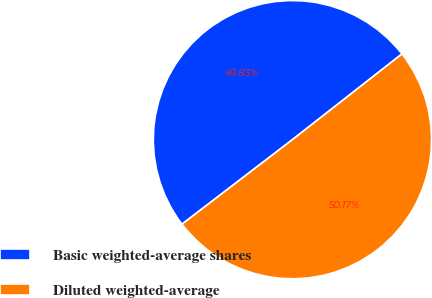Convert chart to OTSL. <chart><loc_0><loc_0><loc_500><loc_500><pie_chart><fcel>Basic weighted-average shares<fcel>Diluted weighted-average<nl><fcel>49.83%<fcel>50.17%<nl></chart> 